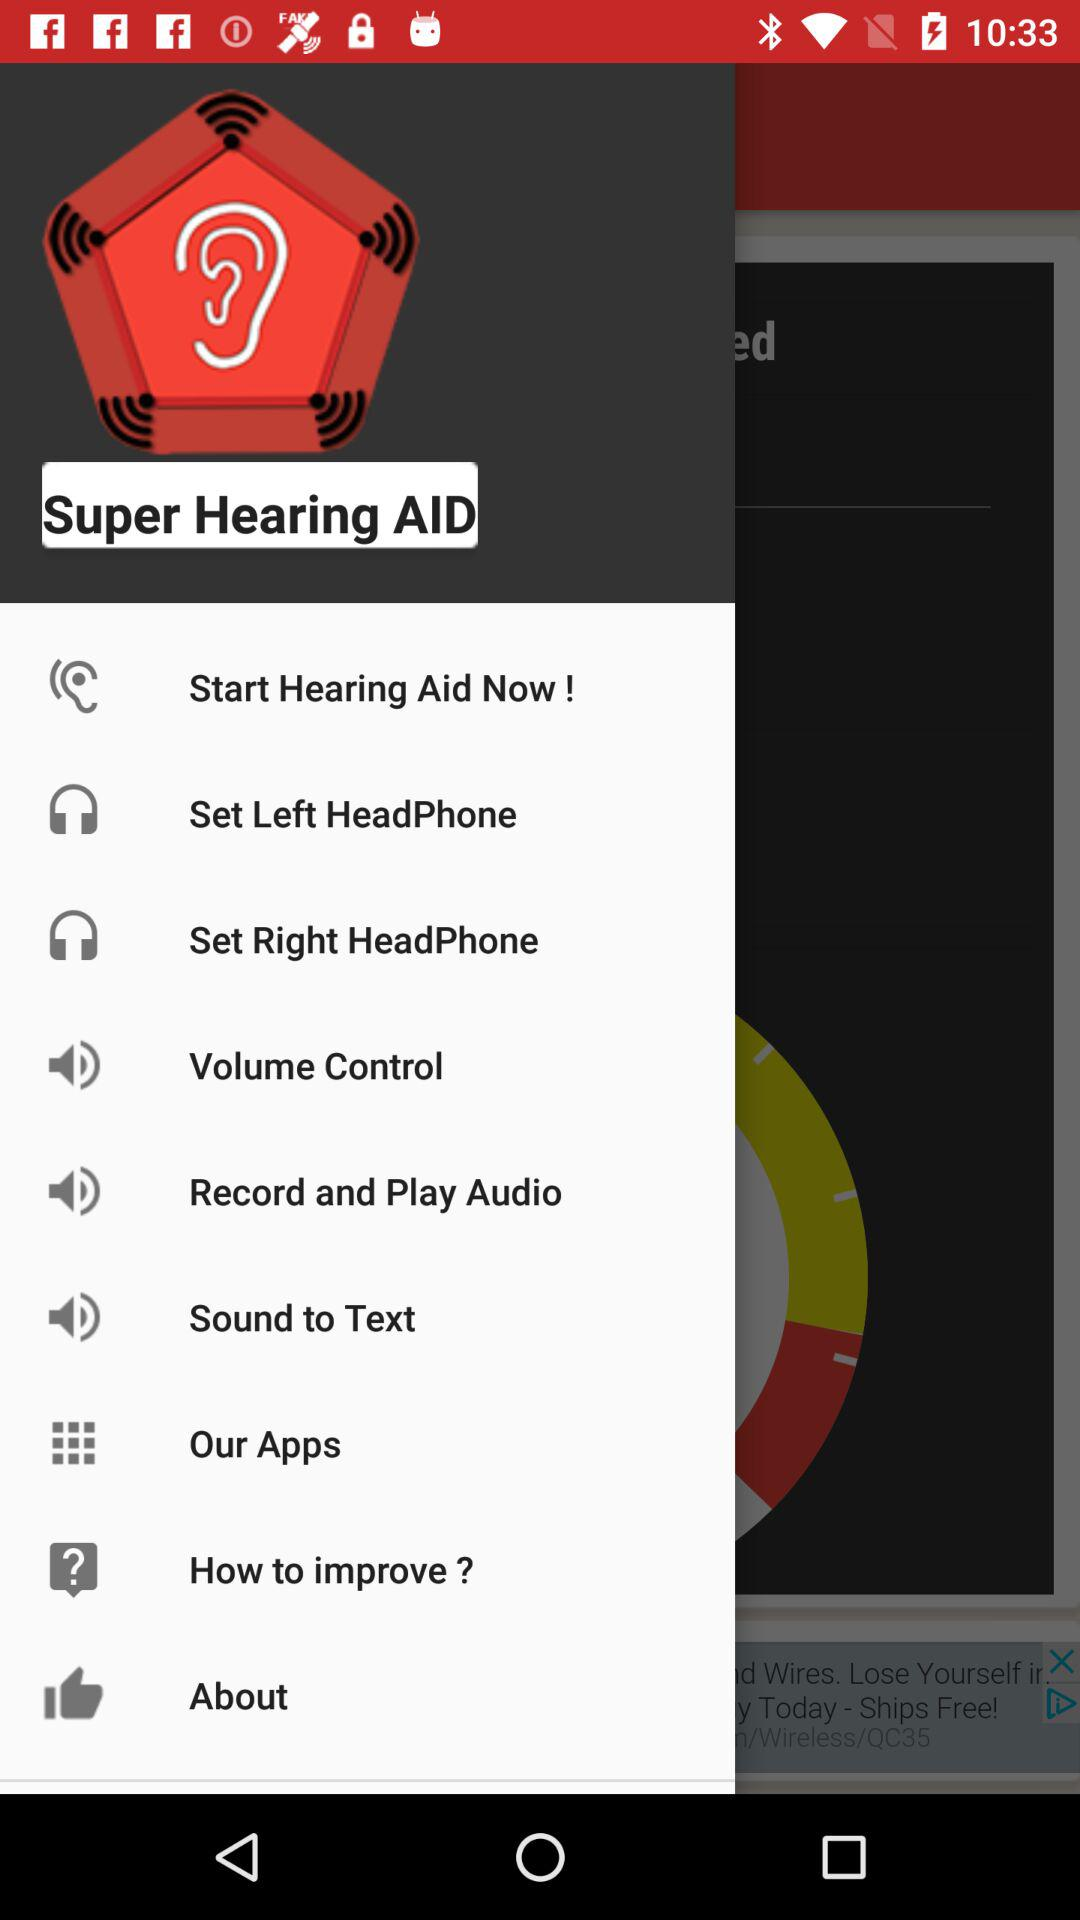What is the name of the application? The name of the application is "Super Hearing AID". 